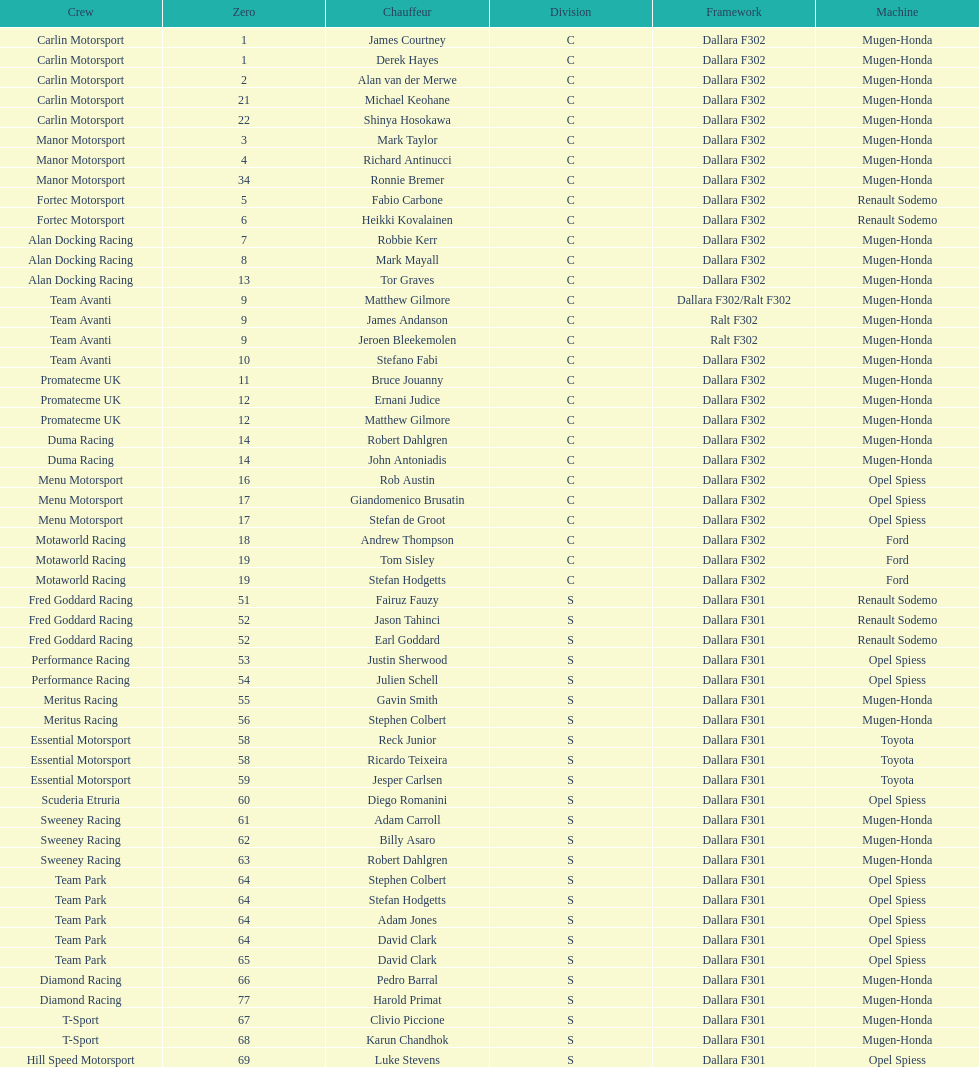How many class s (scholarship) teams are on the chart? 19. 